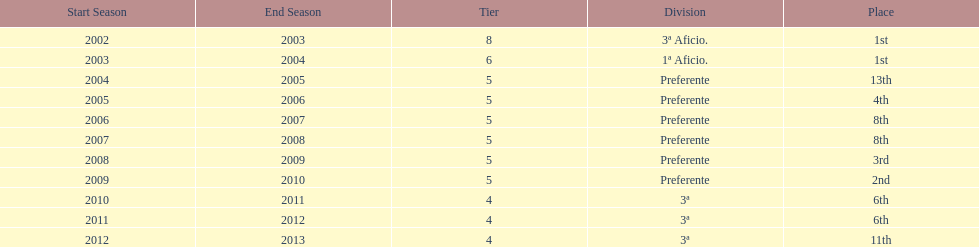How many years was the team in the 3 a division? 4. 